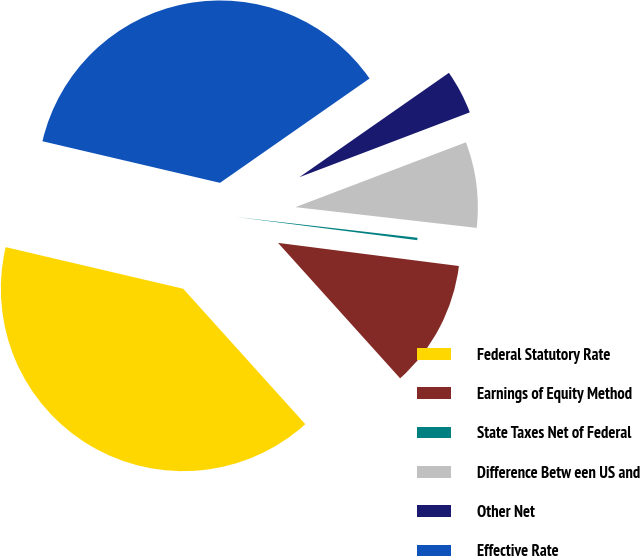Convert chart. <chart><loc_0><loc_0><loc_500><loc_500><pie_chart><fcel>Federal Statutory Rate<fcel>Earnings of Equity Method<fcel>State Taxes Net of Federal<fcel>Difference Betw een US and<fcel>Other Net<fcel>Effective Rate<nl><fcel>40.34%<fcel>11.3%<fcel>0.21%<fcel>7.6%<fcel>3.91%<fcel>36.64%<nl></chart> 